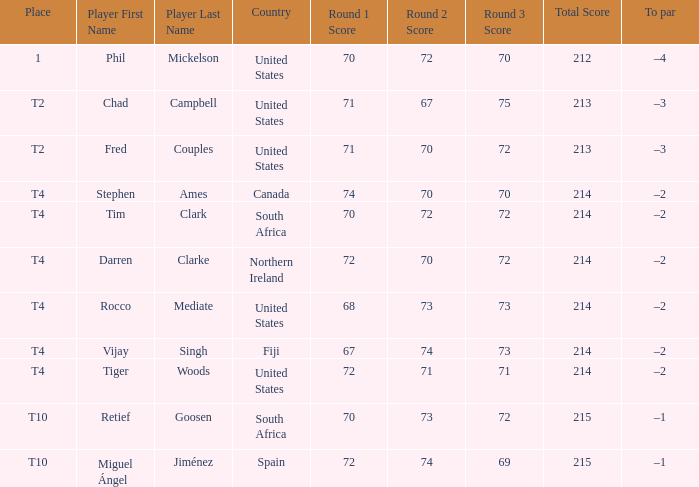What country does Rocco Mediate play for? United States. 